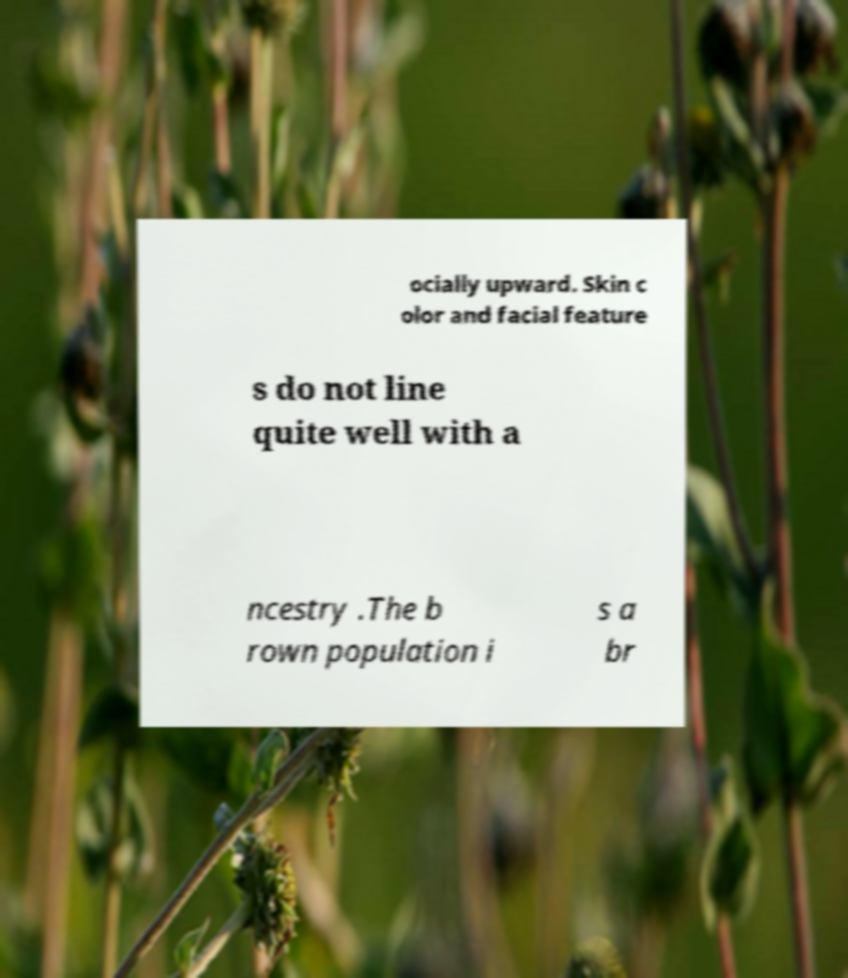Could you extract and type out the text from this image? ocially upward. Skin c olor and facial feature s do not line quite well with a ncestry .The b rown population i s a br 